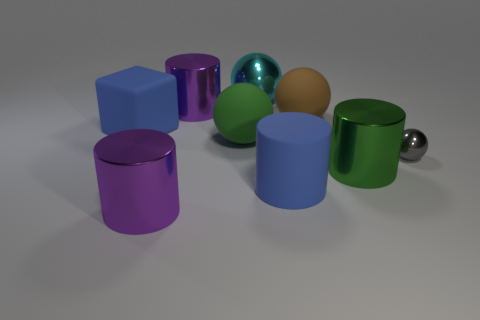Subtract all gray cubes. Subtract all red cylinders. How many cubes are left? 1 Add 1 small purple metallic blocks. How many objects exist? 10 Subtract all blocks. How many objects are left? 8 Subtract 0 cyan blocks. How many objects are left? 9 Subtract all green spheres. Subtract all red things. How many objects are left? 8 Add 5 brown things. How many brown things are left? 6 Add 9 big rubber cylinders. How many big rubber cylinders exist? 10 